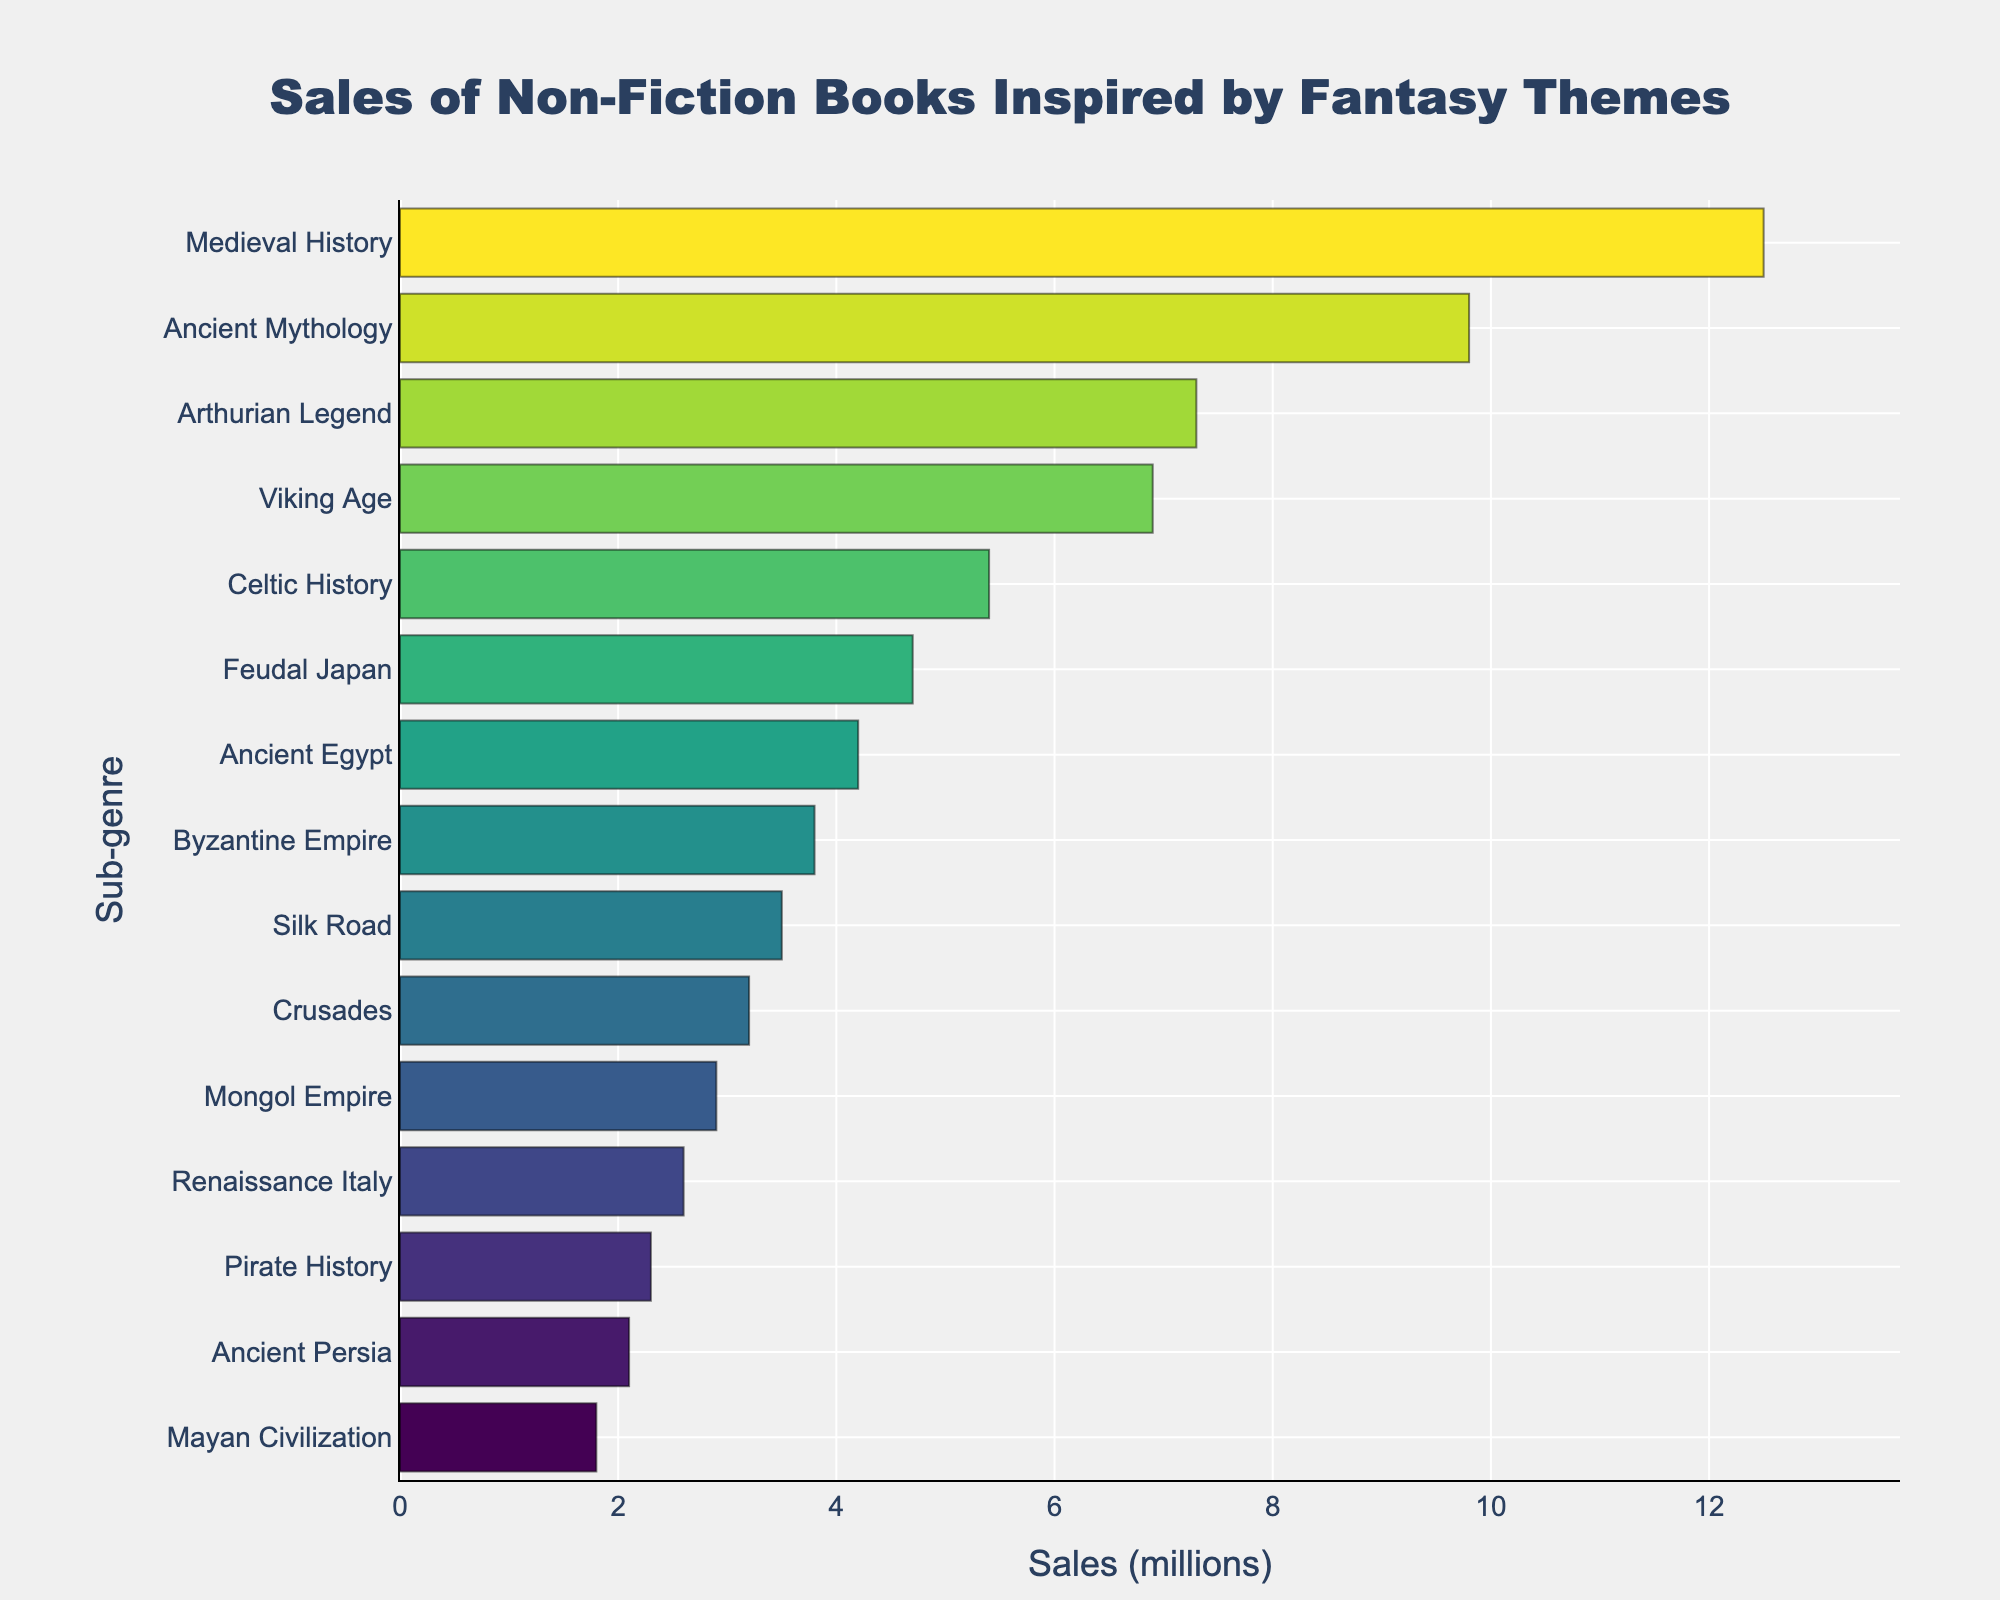Which sub-genre has the highest sales? According to the bar chart, the sub-genre with the longest bar (meaning the highest sales) is 'Medieval History' with 12.5 million.
Answer: Medieval History Which sub-genre has the lowest sales? Looking at the bar chart, the sub-genre with the shortest bar (meaning the lowest sales) is 'Mayan Civilization' with 1.8 million.
Answer: Mayan Civilization What is the difference in sales between Medieval History and Viking Age? Medieval History has sales of 12.5 million and Viking Age has sales of 6.9 million. The difference is 12.5 - 6.9 = 5.6 million.
Answer: 5.6 million What is the average sales figure for all the sub-genres? Sum all sales values: 12.5 + 9.8 + 7.3 + 6.9 + 5.4 + 4.7 + 4.2 + 3.8 + 3.5 + 3.2 + 2.9 + 2.6 + 2.3 + 2.1 + 1.8 = 72.0. Divide by the number of sub-genres: 72.0 / 15 = 4.8 million.
Answer: 4.8 million Are the sales of Ancient Mythology greater than the combined sales of Feudal Japan and Pirate History? Ancient Mythology has sales of 9.8 million, while Feudal Japan and Pirate History combined have 4.7 + 2.3 = 7.0 million. Since 9.8 million is greater than 7.0 million, the answer is yes.
Answer: Yes How many sub-genres have sales greater than 5 million? Counting the bars longer than the 5 million mark, we see six sub-genres: Medieval History, Ancient Mythology, Arthurian Legend, Viking Age, Celtic History, and Feudal Japan.
Answer: 6 What is the total sales figure for sub-genres related to Ancient history (Ancient Mythology, Ancient Egypt, Ancient Persia)? Sum the sales of these sub-genres: Ancient Mythology (9.8) + Ancient Egypt (4.2) + Ancient Persia (2.1) = 16.1 million.
Answer: 16.1 million Which sub-genre lies at the median of the sales data? When sorted by sales, the median is the 8th out of 15 values. The sub-genre at position 8 is Byzantine Empire with 3.8 million sales.
Answer: Byzantine Empire What is the total sales figure for all sub-genres exceeding 3 million? Sum the sales of sub-genres with sales greater than 3 million: 12.5 + 9.8 + 7.3 + 6.9 + 5.4 + 4.7 + 4.2 + 3.8 + 3.5 = 58.1 million.
Answer: 58.1 million What is the range of sales figures among the sub-genres? The range is calculated by subtracting the smallest value from the largest value. The largest is Medieval History (12.5 million) and the smallest is Mayan Civilization (1.8 million). Thus, range = 12.5 - 1.8 = 10.7 million.
Answer: 10.7 million 